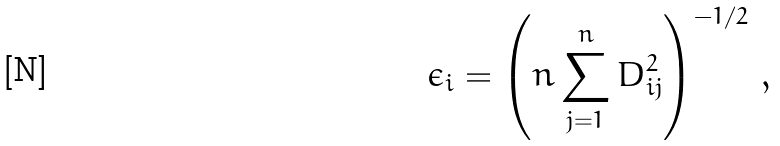Convert formula to latex. <formula><loc_0><loc_0><loc_500><loc_500>\epsilon _ { i } = \left ( n \sum _ { j = 1 } ^ { n } D ^ { 2 } _ { i j } \right ) ^ { - 1 / 2 } \, ,</formula> 